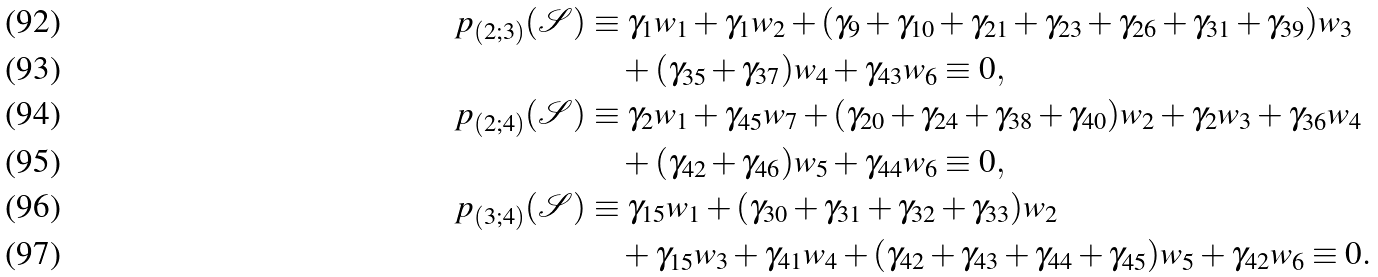<formula> <loc_0><loc_0><loc_500><loc_500>p _ { ( 2 ; 3 ) } ( \mathcal { S } ) & \equiv \gamma _ { 1 } w _ { 1 } + \gamma _ { 1 } w _ { 2 } + ( \gamma _ { 9 } + \gamma _ { 1 0 } + \gamma _ { 2 1 } + \gamma _ { 2 3 } + \gamma _ { 2 6 } + \gamma _ { 3 1 } + \gamma _ { 3 9 } ) w _ { 3 } \\ & \quad + ( \gamma _ { 3 5 } + \gamma _ { 3 7 } ) w _ { 4 } + \gamma _ { 4 3 } w _ { 6 } \equiv 0 , \\ p _ { ( 2 ; 4 ) } ( \mathcal { S } ) & \equiv \gamma _ { 2 } w _ { 1 } + \gamma _ { 4 5 } w _ { 7 } + ( \gamma _ { 2 0 } + \gamma _ { 2 4 } + \gamma _ { 3 8 } + \gamma _ { 4 0 } ) w _ { 2 } + \gamma _ { 2 } w _ { 3 } + \gamma _ { 3 6 } w _ { 4 } \\ & \quad + ( \gamma _ { 4 2 } + \gamma _ { 4 6 } ) w _ { 5 } + \gamma _ { 4 4 } w _ { 6 } \equiv 0 , \\ p _ { ( 3 ; 4 ) } ( \mathcal { S } ) & \equiv \gamma _ { 1 5 } w _ { 1 } + ( \gamma _ { 3 0 } + \gamma _ { 3 1 } + \gamma _ { 3 2 } + \gamma _ { 3 3 } ) w _ { 2 } \\ & \quad + \gamma _ { 1 5 } w _ { 3 } + \gamma _ { 4 1 } w _ { 4 } + ( \gamma _ { 4 2 } + \gamma _ { 4 3 } + \gamma _ { 4 4 } + \gamma _ { 4 5 } ) w _ { 5 } + \gamma _ { 4 2 } w _ { 6 } \equiv 0 .</formula> 